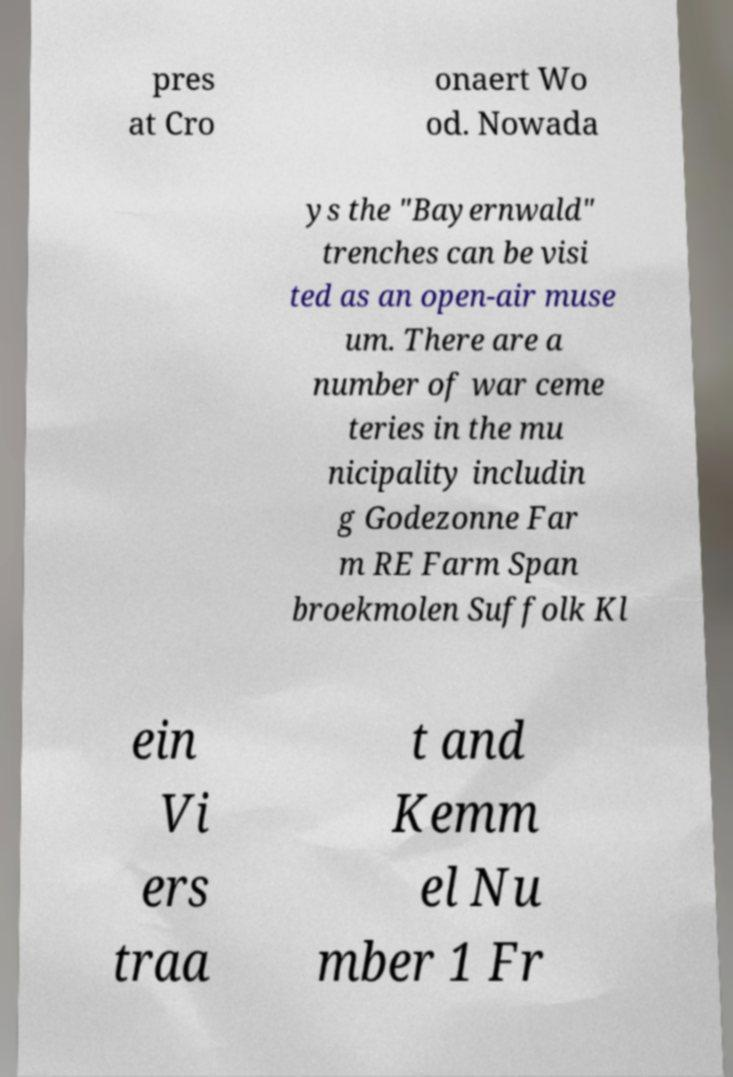Could you assist in decoding the text presented in this image and type it out clearly? pres at Cro onaert Wo od. Nowada ys the "Bayernwald" trenches can be visi ted as an open-air muse um. There are a number of war ceme teries in the mu nicipality includin g Godezonne Far m RE Farm Span broekmolen Suffolk Kl ein Vi ers traa t and Kemm el Nu mber 1 Fr 